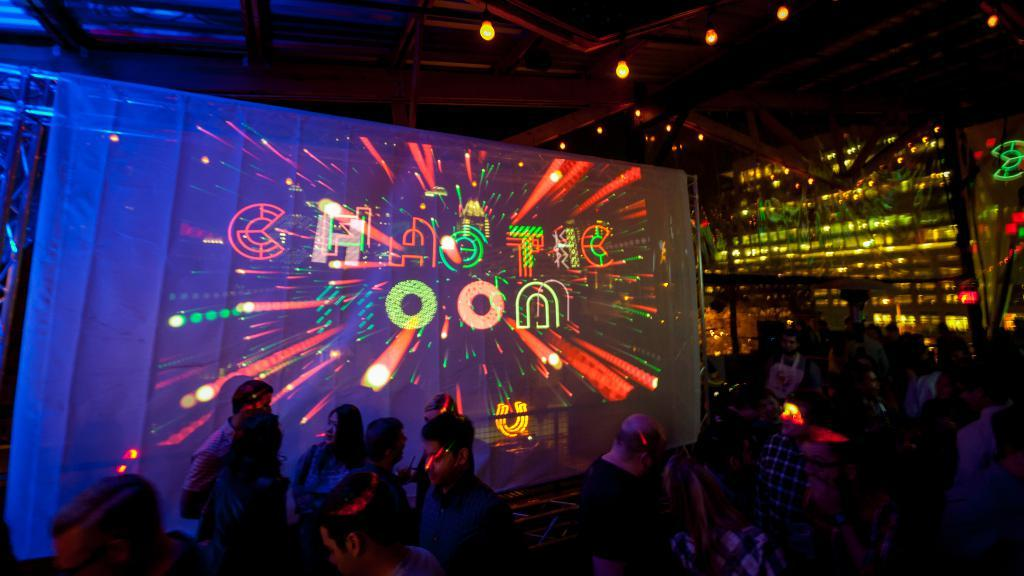<image>
Render a clear and concise summary of the photo. A screen in a darkened room full of people says "Chaotic oon" 